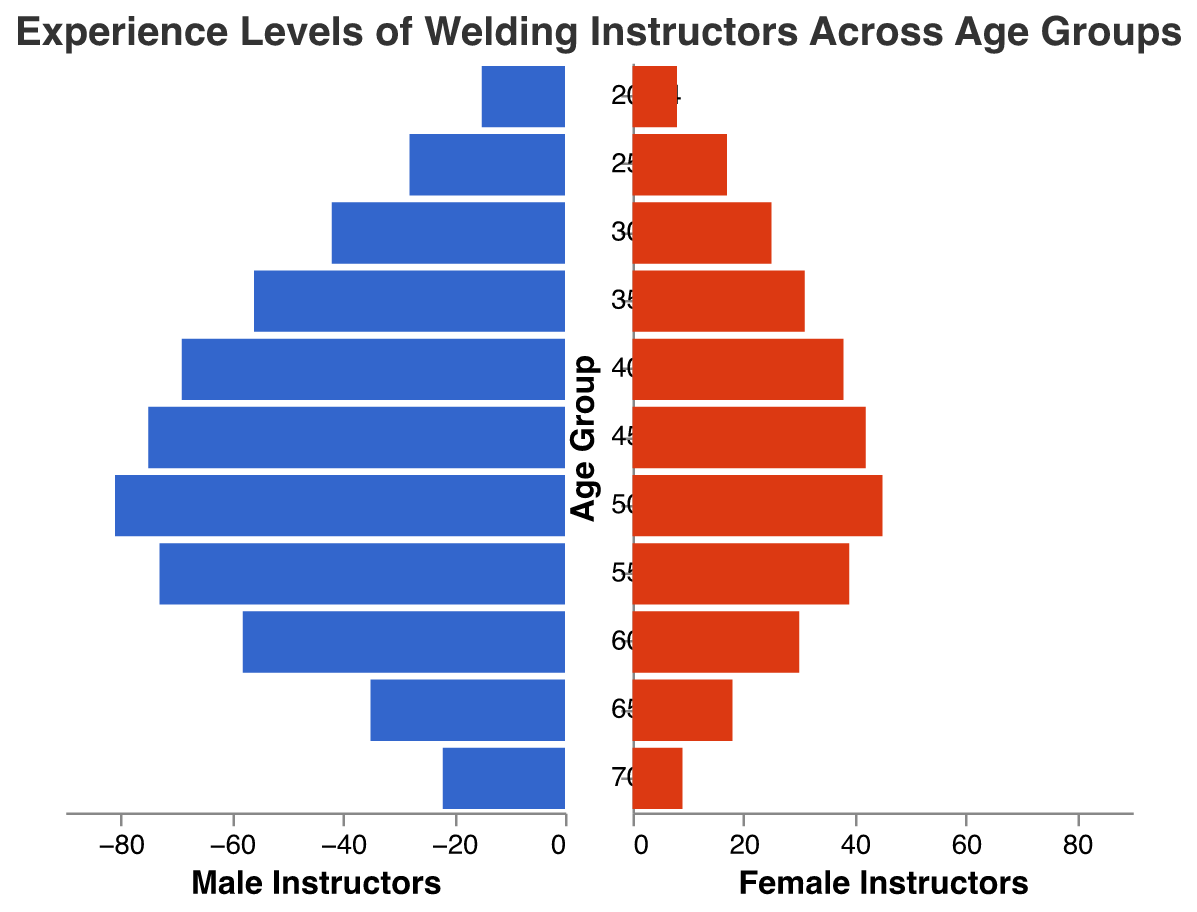What is the title of the figure? The title is usually displayed at the top of the figure and provides a summary of what the data represents. Here, the title is "Experience Levels of Welding Instructors Across Age Groups" which can be read directly from the plot.
Answer: "Experience Levels of Welding Instructors Across Age Groups" How many male instructors are there in the 45-49 age group? Refer to the specific age group "45-49" and read off the value for male instructors. The value for male instructors in this group is 75 as per the data provided.
Answer: 75 Which age group has the most female instructors, and how many are there? To answer this, look for the highest value in the Female Instructors column. The 50-54 age group has the most female instructors with 45.
Answer: 50-54, 45 Are there more male or female instructors in the 60-64 age group and by how much? For the 60-64 age group, the number of male instructors is 58 and the number of female instructors is 30. The difference is 58 - 30 = 28, so there are 28 more male instructors.
Answer: More male instructors by 28 What is the difference in the number of male and female instructors in the 35-39 age group? For the 35-39 age group, the number of male instructors is 56 and female instructors is 31. The difference is 56 - 31 = 25.
Answer: 25 In which age group do male instructors exceed 70, and how many such groups are there? From the Male Instructors column, identify age groups where the value exceeds 70. These age groups are 45-49 and 50-54. So, there are 2 such groups.
Answer: 45-49, 50-54, 2 What is the total number of instructors (male and female) in the 30-34 age group? Add the number of male and female instructors for the 30-34 age group. The total is 42 (male) + 25 (female) = 67.
Answer: 67 Which age group has the least number of male instructors? Find the smallest value in the Male Instructors column. The age group with the least number of male instructors is 20-24 with 15 instructors.
Answer: 20-24 By how much do female instructors in the 55-59 age group differ from those in the 50-54 age group? Subtract the number of female instructors in the 50-54 age group (45) from those in the 55-59 age group (39). The difference is 45 - 39 = 6.
Answer: 6 Which age group has an equal number of male and female instructors? Compare the values in the Male and Female Instructors columns for each age group. None of the age groups have an equal number of male and female instructors.
Answer: None 